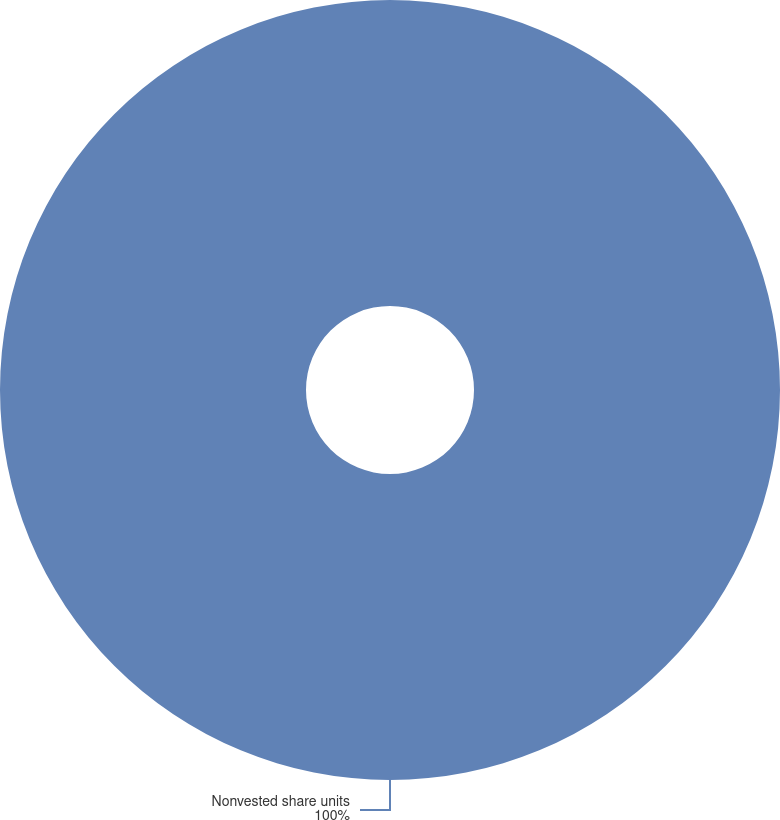<chart> <loc_0><loc_0><loc_500><loc_500><pie_chart><fcel>Nonvested share units<nl><fcel>100.0%<nl></chart> 